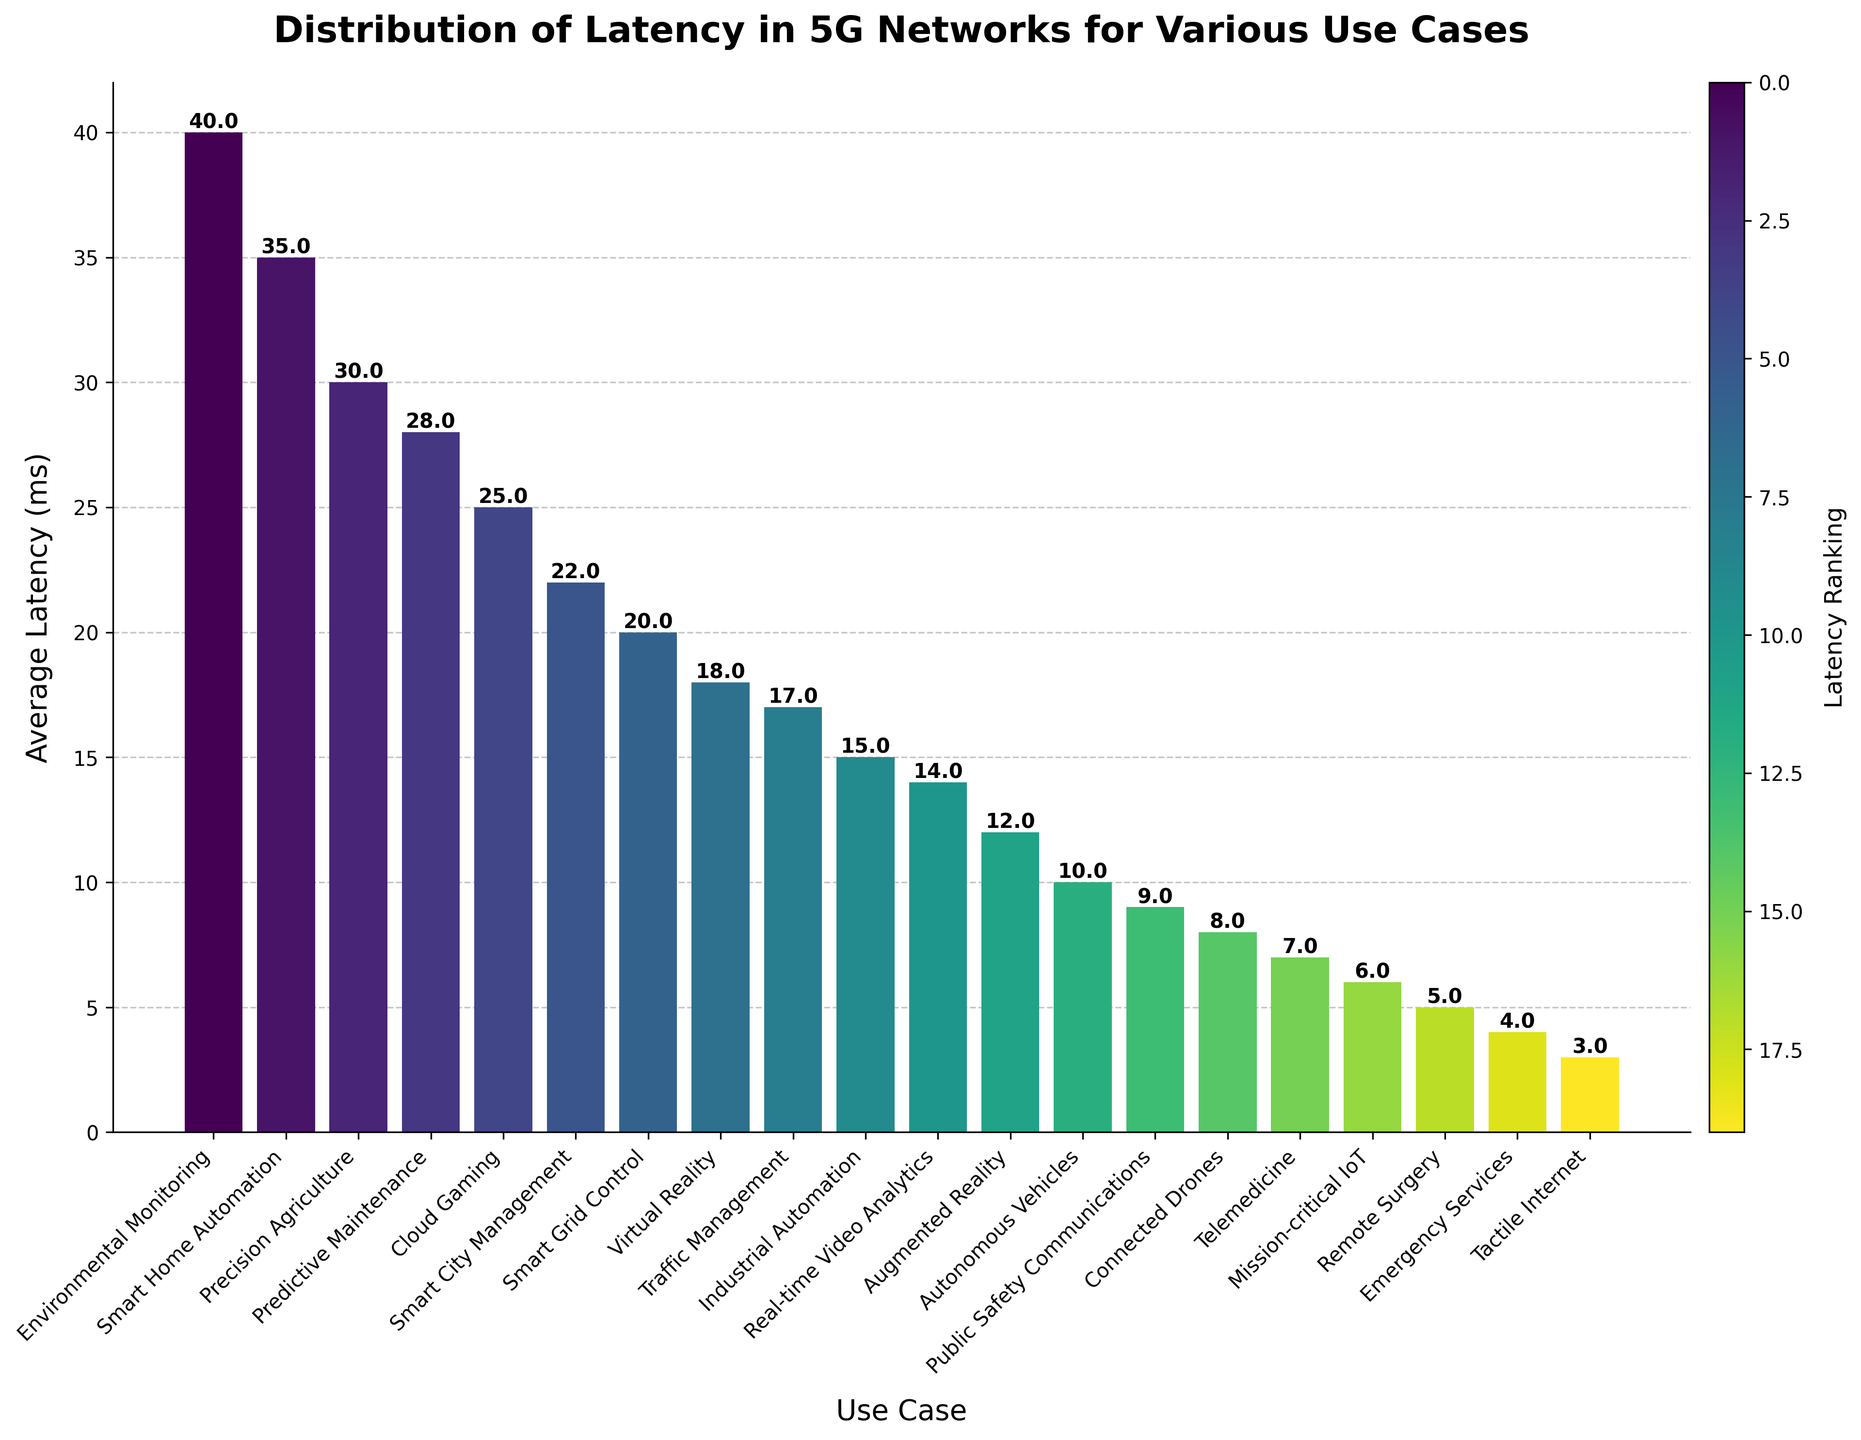Which use case has the highest average latency? Look for the tallest bar in the bar chart. The data associated with the tallest bar represents the use case with the highest average latency.
Answer: Environmental Monitoring Which use case has a higher average latency, Remote Surgery or Emergency Services? Compare the height of the bars representing Remote Surgery and Emergency Services. The bar with greater height indicates the higher average latency.
Answer: Remote Surgery What is the difference in average latency between Cloud Gaming and Tactile Internet? Find the bars for Cloud Gaming and Tactile Internet. Subtract the height (average latency in ms) of Tactile Internet from that of Cloud Gaming.
Answer: 22 ms What is the combined average latency for Smart Home Automation and Predictive Maintenance? Locate the bars for Smart Home Automation and Predictive Maintenance. Sum their heights (average latency in ms).
Answer: 63 ms Which use case has the lowest average latency? Identify the shortest bar in the chart. The use case associated with this bar has the lowest average latency.
Answer: Tactile Internet How does the average latency for Virtual Reality compare to that for Traffic Management? Compare the height of the bars for Virtual Reality and Traffic Management. Determine which bar is taller and by how much.
Answer: Virtual Reality is higher by 1 ms How many use cases have an average latency lower than 10 ms? Count the number of bars with heights (average latency in ms) less than 10 ms.
Answer: 7 By how much does the average latency for Smart City Management exceed that for Connected Drones? Locate the bars for Smart City Management and Connected Drones. Subtract the height (average latency in ms) of Connected Drones from that of Smart City Management.
Answer: 14 ms What is the median average latency among the given use cases? Arrange the heights (average latency in ms) of all bars in ascending order and find the middle value. Since there are 20 use cases (an even number), the median will be the average of the 10th and 11th values.
Answer: 14 ms What is the average latency in ms across all use cases? Sum the heights (average latency in ms) of all bars and divide by the number of use cases (20).
Answer: 16 ms 